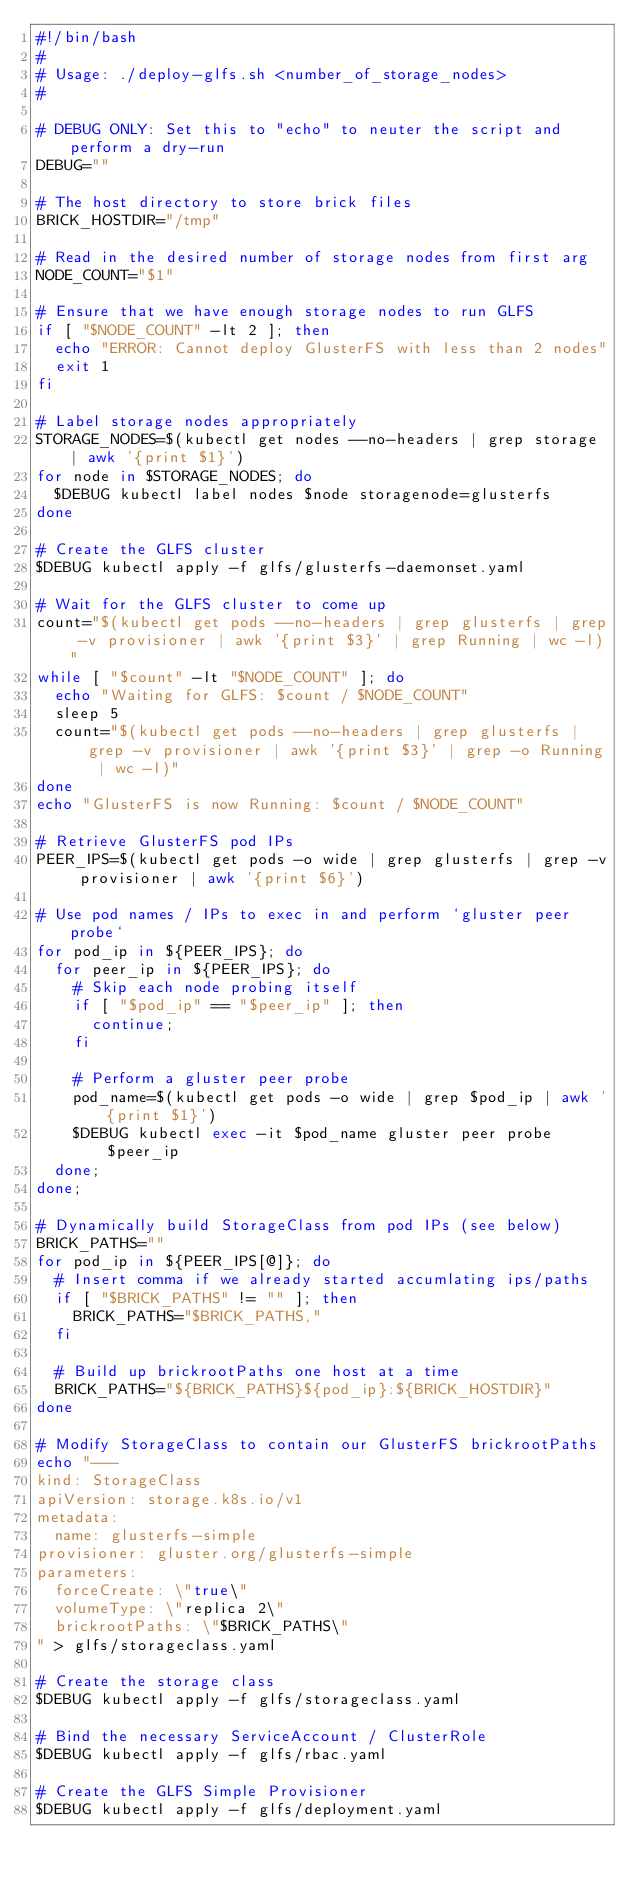Convert code to text. <code><loc_0><loc_0><loc_500><loc_500><_Bash_>#!/bin/bash
#
# Usage: ./deploy-glfs.sh <number_of_storage_nodes>
# 

# DEBUG ONLY: Set this to "echo" to neuter the script and perform a dry-run
DEBUG=""

# The host directory to store brick files
BRICK_HOSTDIR="/tmp"

# Read in the desired number of storage nodes from first arg
NODE_COUNT="$1"

# Ensure that we have enough storage nodes to run GLFS
if [ "$NODE_COUNT" -lt 2 ]; then
  echo "ERROR: Cannot deploy GlusterFS with less than 2 nodes"
  exit 1
fi

# Label storage nodes appropriately
STORAGE_NODES=$(kubectl get nodes --no-headers | grep storage | awk '{print $1}')
for node in $STORAGE_NODES; do
  $DEBUG kubectl label nodes $node storagenode=glusterfs 
done

# Create the GLFS cluster
$DEBUG kubectl apply -f glfs/glusterfs-daemonset.yaml

# Wait for the GLFS cluster to come up
count="$(kubectl get pods --no-headers | grep glusterfs | grep -v provisioner | awk '{print $3}' | grep Running | wc -l)"
while [ "$count" -lt "$NODE_COUNT" ]; do
  echo "Waiting for GLFS: $count / $NODE_COUNT"
  sleep 5
  count="$(kubectl get pods --no-headers | grep glusterfs | grep -v provisioner | awk '{print $3}' | grep -o Running | wc -l)"
done
echo "GlusterFS is now Running: $count / $NODE_COUNT"

# Retrieve GlusterFS pod IPs
PEER_IPS=$(kubectl get pods -o wide | grep glusterfs | grep -v provisioner | awk '{print $6}')

# Use pod names / IPs to exec in and perform `gluster peer probe`
for pod_ip in ${PEER_IPS}; do
  for peer_ip in ${PEER_IPS}; do
    # Skip each node probing itself
    if [ "$pod_ip" == "$peer_ip" ]; then
      continue;
    fi

    # Perform a gluster peer probe
    pod_name=$(kubectl get pods -o wide | grep $pod_ip | awk '{print $1}')
    $DEBUG kubectl exec -it $pod_name gluster peer probe $peer_ip
  done;
done;

# Dynamically build StorageClass from pod IPs (see below)
BRICK_PATHS=""
for pod_ip in ${PEER_IPS[@]}; do
  # Insert comma if we already started accumlating ips/paths
  if [ "$BRICK_PATHS" != "" ]; then
    BRICK_PATHS="$BRICK_PATHS,"
  fi

  # Build up brickrootPaths one host at a time
  BRICK_PATHS="${BRICK_PATHS}${pod_ip}:${BRICK_HOSTDIR}"
done

# Modify StorageClass to contain our GlusterFS brickrootPaths
echo "---
kind: StorageClass
apiVersion: storage.k8s.io/v1
metadata:
  name: glusterfs-simple
provisioner: gluster.org/glusterfs-simple
parameters:
  forceCreate: \"true\"
  volumeType: \"replica 2\"
  brickrootPaths: \"$BRICK_PATHS\"
" > glfs/storageclass.yaml

# Create the storage class
$DEBUG kubectl apply -f glfs/storageclass.yaml

# Bind the necessary ServiceAccount / ClusterRole
$DEBUG kubectl apply -f glfs/rbac.yaml

# Create the GLFS Simple Provisioner
$DEBUG kubectl apply -f glfs/deployment.yaml
</code> 